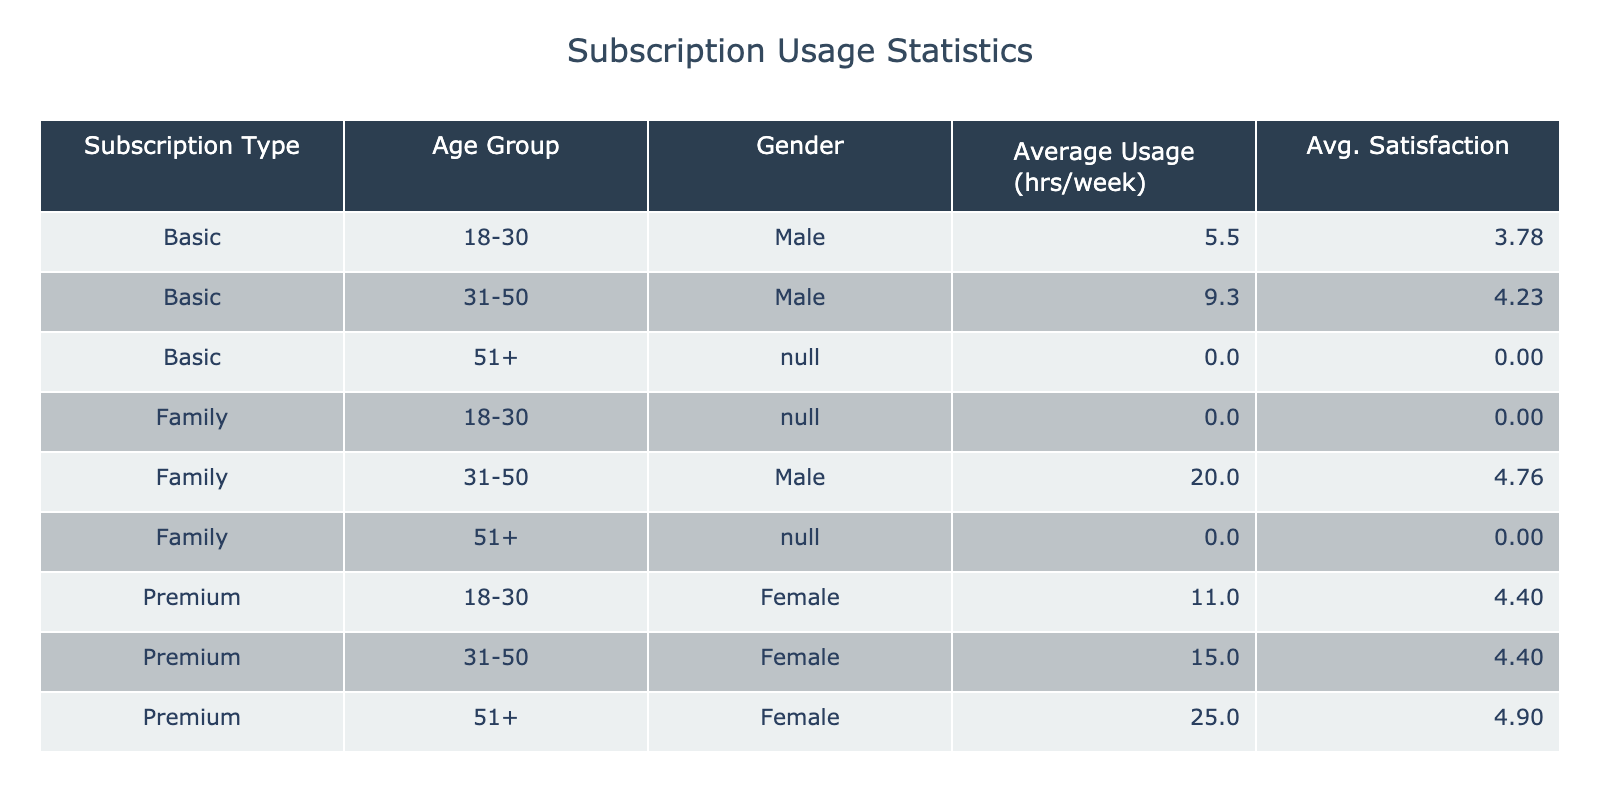What is the average usage for the Premium subscription type? Looking at the table, there are two Premium subscription types grouped by age. The average usage hours for Premium are 15 (from Age group 18-30) and 16.5 (from Age group 31-50). The average of these two values is (15 + 16.5) / 2 = 15.75
Answer: 15.75 Which gender is predominantly using the Family subscription? The table reveals that in the Family subscription category, the Gender listed is Male as the most frequent occurrence (C004, C007, C013, C016 all report male). Therefore, Male is the predominant gender.
Answer: Male What is the satisfaction score for the Basic subscription type? For the Basic subscription type, there are three age groups: 18-30, 31-50, and 51+. The satisfaction scores for these groups can be found in the table: 4.2 (for 18-30), 4.1 (for 31-50), and a possible lower score for 51+, but only the two scores provided give an average of (4.2 + 4.1) / 2 = 4.15 for the Basic subscription type.
Answer: 4.15 Is there any age group with a higher average usage hour for Family subscriptions compared to Premium subscriptions? Yes, the Family subscription for age groups 31-50 and 51+ averages at 20 and 22 hours, respectively. In contrast, Premium for age groups 18-30 averages at 15, and 31-50 averages at 16.5; thus, Family has higher average usages.
Answer: Yes What is the average Customer Satisfaction Score for customers aged 31-50 across all subscription types? Looking across the table, for the age group 31-50, the Premium type has a score of 4.4, Family is 4.6; Basic has no representation. Therefore, the average of the present satisfaction scores is (4.4 + 4.6) / 2 = 4.5
Answer: 4.5 Are females more satisfied than males based on the reported satisfaction scores? By checking the table, Female satisfaction scores average to 4.5 compared to Male's average of 4.4. Therefore, females score higher on satisfaction than males.
Answer: Yes What is the average income of Premium subscribers in the 31-50 age group? From the table, there is only one premium customer in this age group (C011) with an annual income of 72000. Therefore, the average income remains the same at 72000.
Answer: 72000 What is the difference in average usage hours per week between Basic and Family subscriptions? The average usage hours for the Basic subscription for age group 18-30 is 6.0, and for Family is averaged across groups 31-50 and 51+, which gives 21.0. Therefore, calculating the difference yields 21.0 - 6.0 = 15.0 hours.
Answer: 15.0 Which demographic region has the highest average satisfaction score, and what is it? By analyzing the table, we find that the South region has premium and family subscriptions yielding a consistently high score (4.8), thus having the highest average satisfaction score at that region.
Answer: South, 4.8 